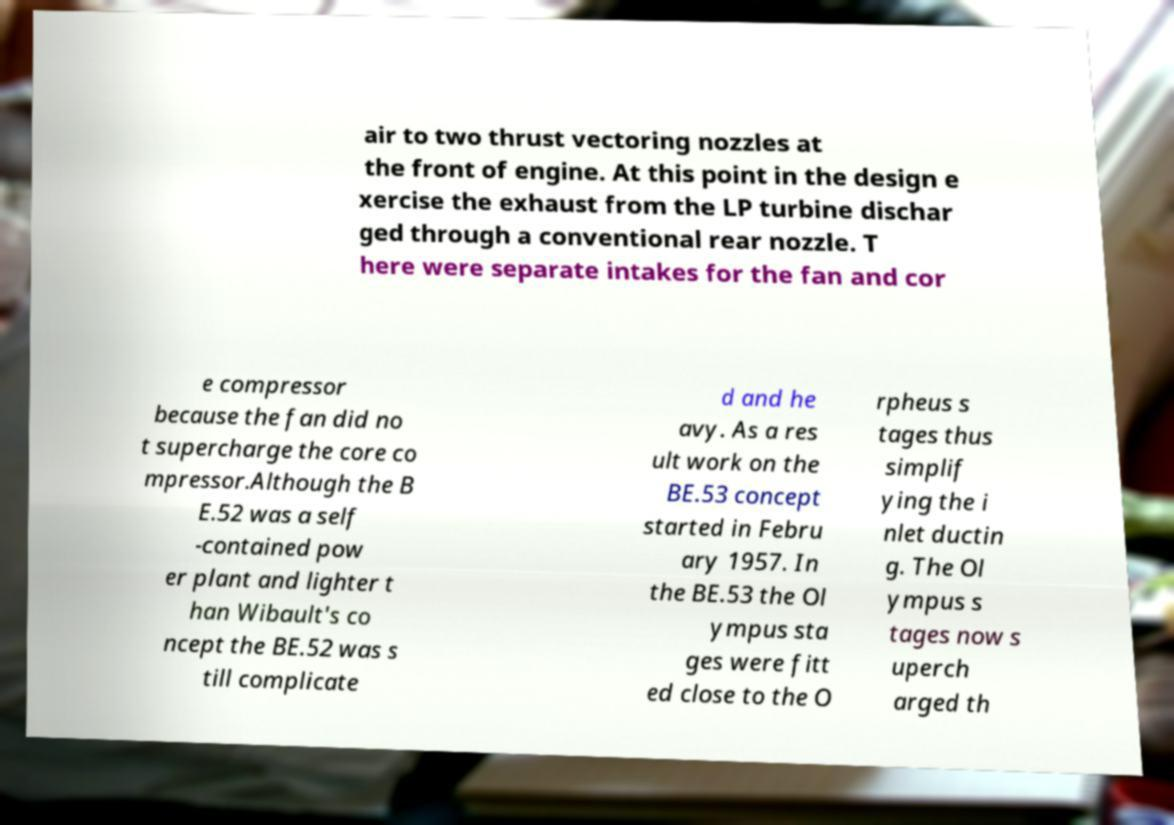I need the written content from this picture converted into text. Can you do that? air to two thrust vectoring nozzles at the front of engine. At this point in the design e xercise the exhaust from the LP turbine dischar ged through a conventional rear nozzle. T here were separate intakes for the fan and cor e compressor because the fan did no t supercharge the core co mpressor.Although the B E.52 was a self -contained pow er plant and lighter t han Wibault's co ncept the BE.52 was s till complicate d and he avy. As a res ult work on the BE.53 concept started in Febru ary 1957. In the BE.53 the Ol ympus sta ges were fitt ed close to the O rpheus s tages thus simplif ying the i nlet ductin g. The Ol ympus s tages now s uperch arged th 